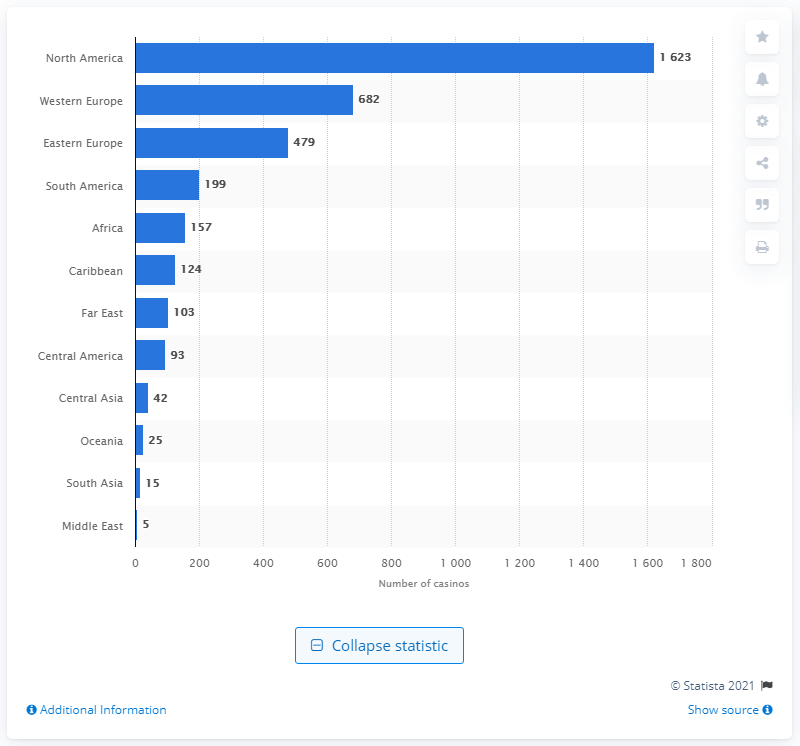Highlight a few significant elements in this photo. In 2011, North America had the most casinos out of all the regions. 